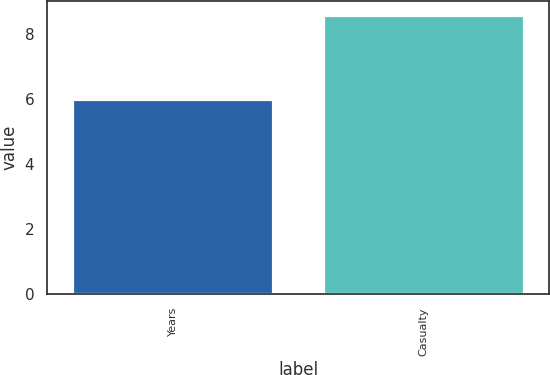<chart> <loc_0><loc_0><loc_500><loc_500><bar_chart><fcel>Years<fcel>Casualty<nl><fcel>6<fcel>8.6<nl></chart> 